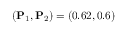<formula> <loc_0><loc_0><loc_500><loc_500>( P _ { 1 } , P _ { 2 } ) = ( 0 . 6 2 , 0 . 6 )</formula> 